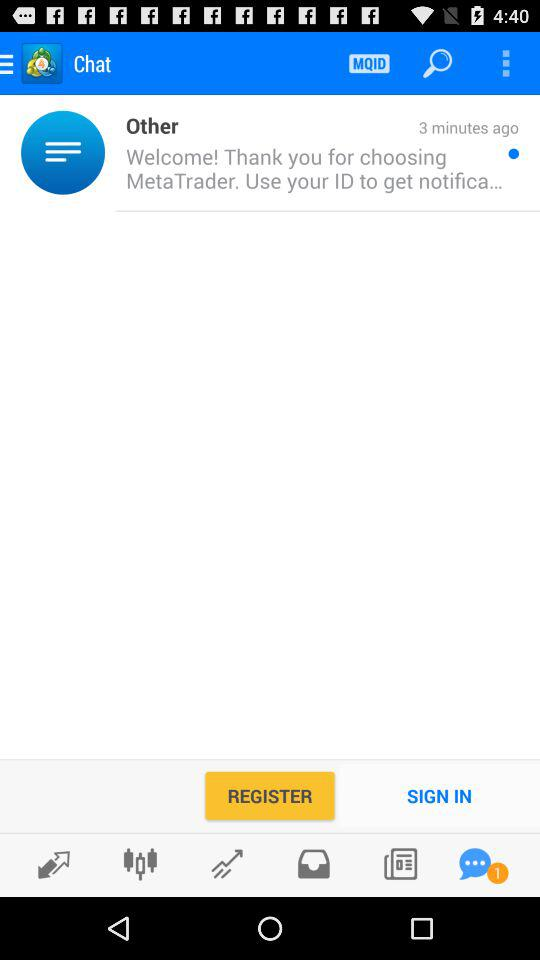What is the application name? The application name is "MetaTrader 4". 